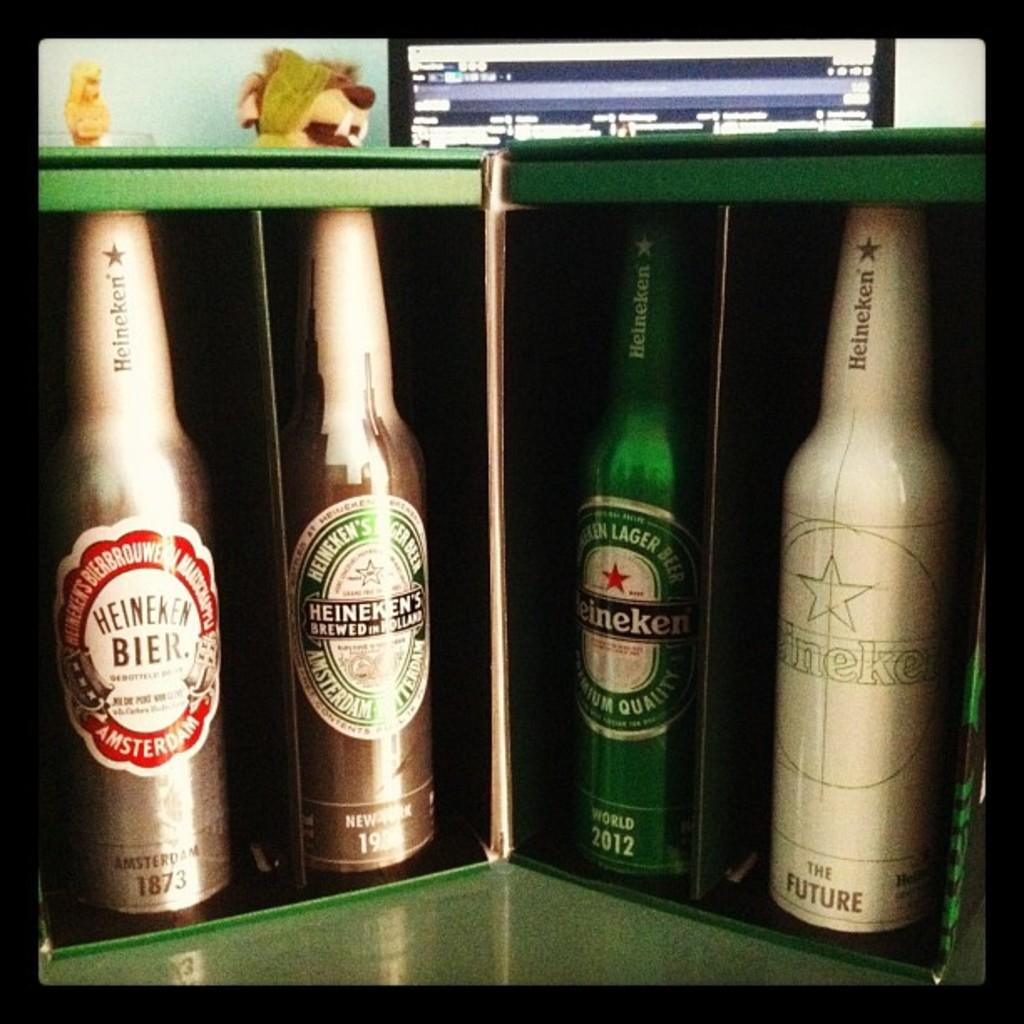<image>
Summarize the visual content of the image. A gift box holds four different varieties of Heineken beer. 